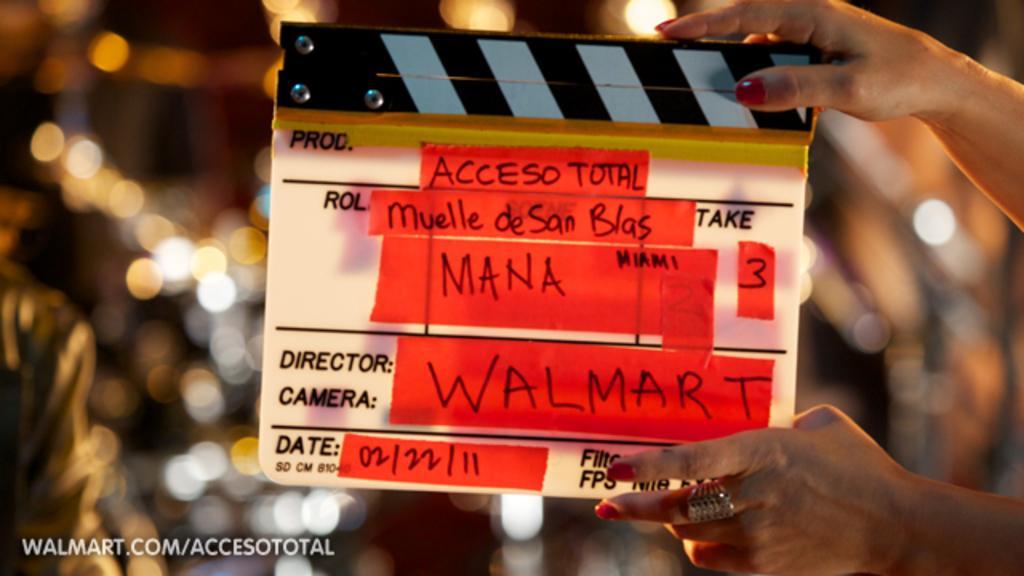Describe this image in one or two sentences. In the image I can see a person hand in which there is a hand clapboard on which there is something written and behind there are some lights. 